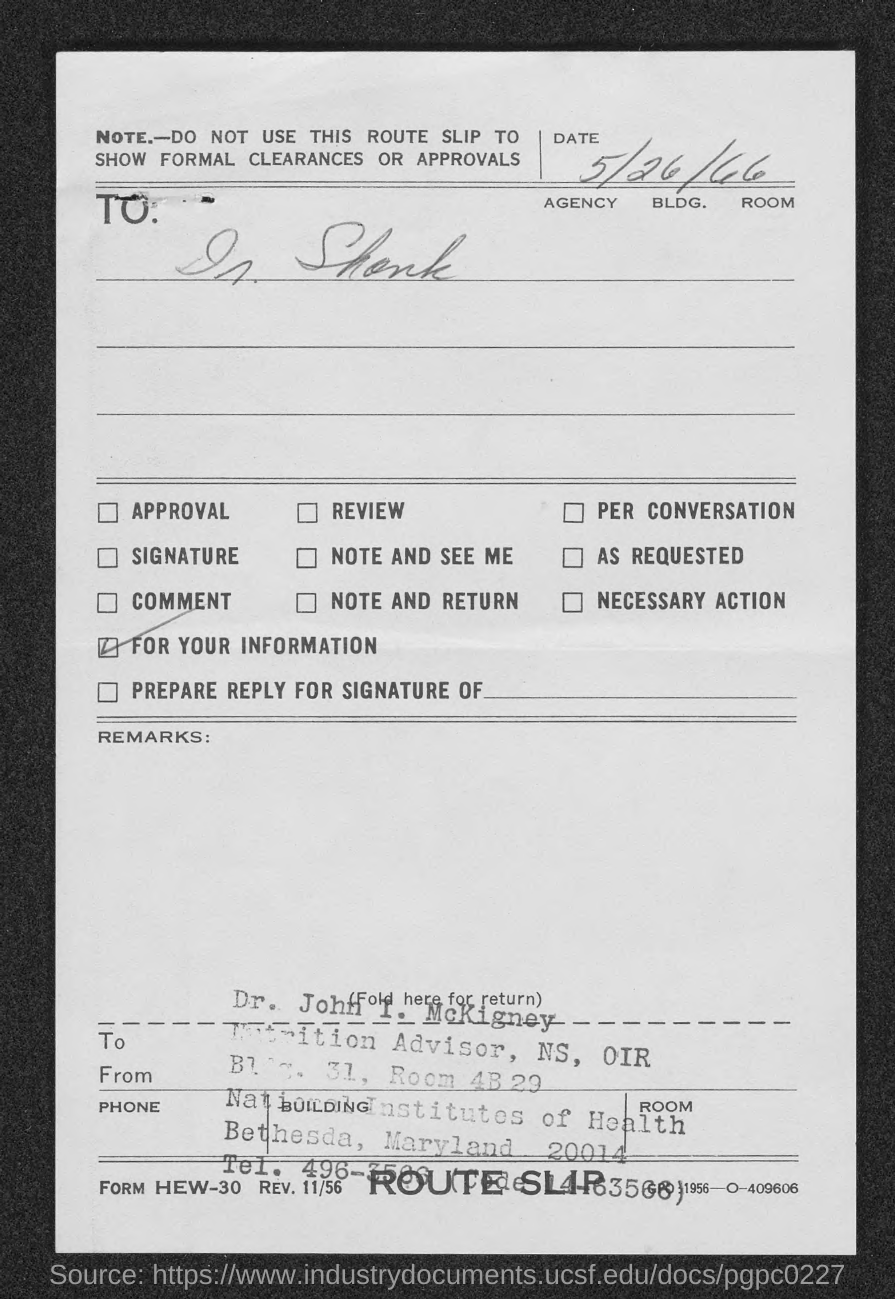Outline some significant characteristics in this image. The name "Dr. John I. McKigney" has been written with a stamp. The National Institutes of Health is located in Bethesda, Maryland. The date mentioned in the slip is May 26, 1966. 